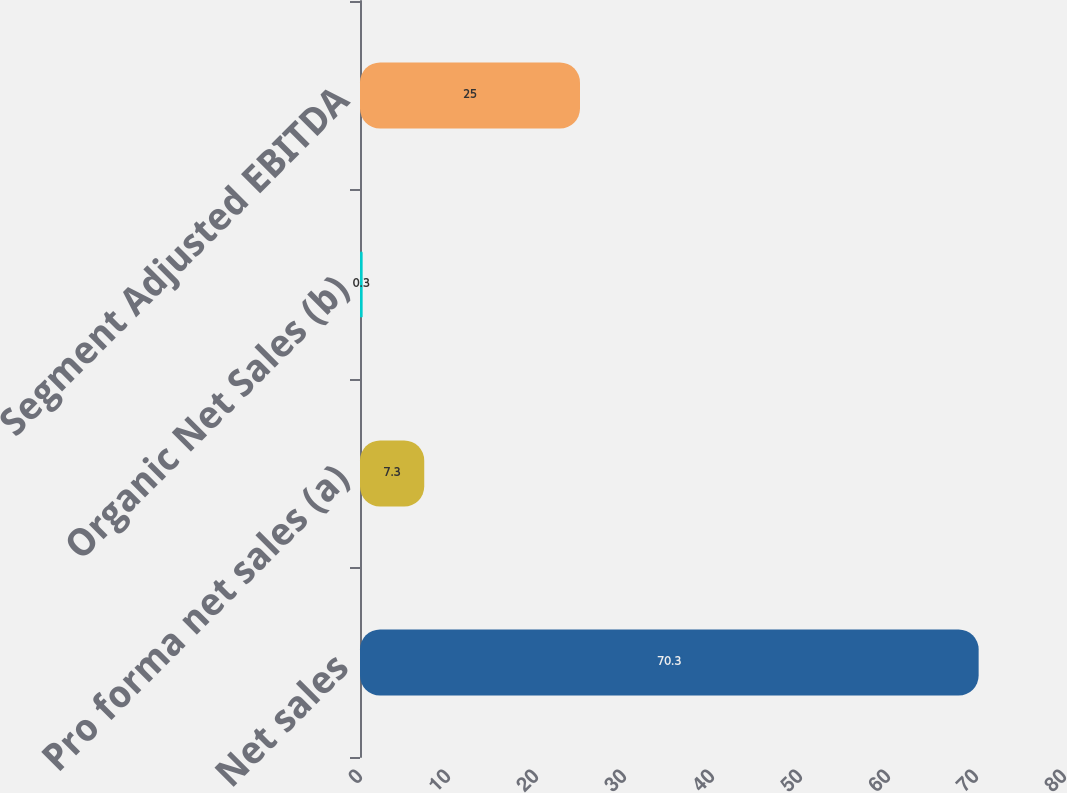<chart> <loc_0><loc_0><loc_500><loc_500><bar_chart><fcel>Net sales<fcel>Pro forma net sales (a)<fcel>Organic Net Sales (b)<fcel>Segment Adjusted EBITDA<nl><fcel>70.3<fcel>7.3<fcel>0.3<fcel>25<nl></chart> 